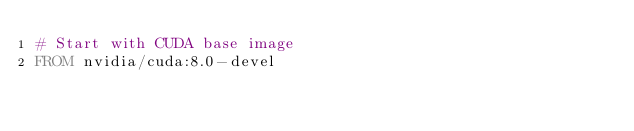Convert code to text. <code><loc_0><loc_0><loc_500><loc_500><_Dockerfile_># Start with CUDA base image
FROM nvidia/cuda:8.0-devel</code> 